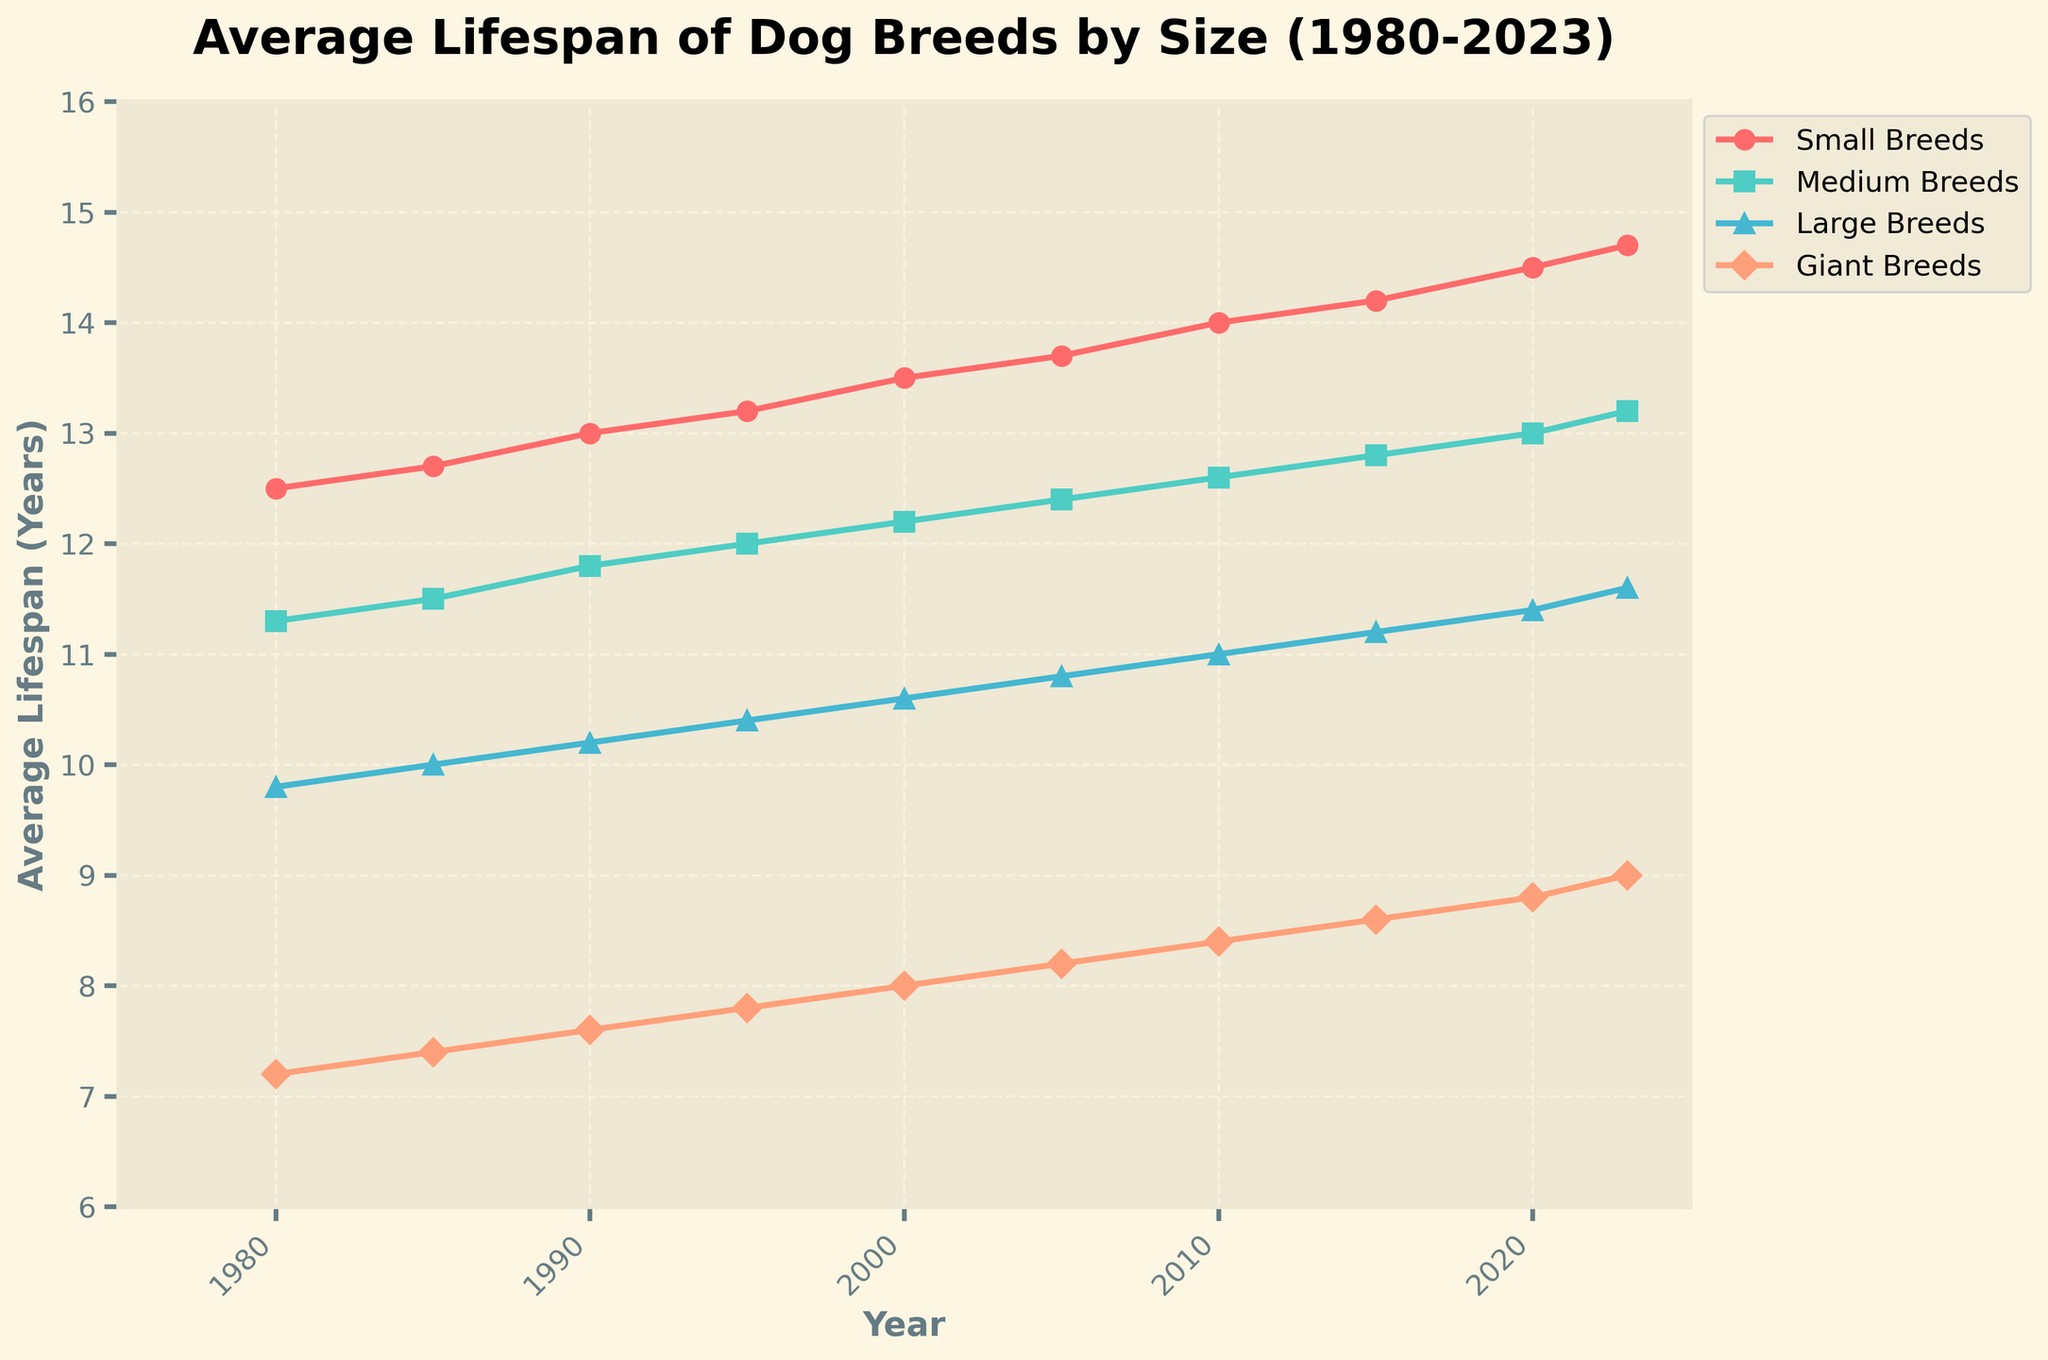What was the average lifespan of Small Breeds in 1980? According to the figure, the average lifespan of Small Breeds in 1980 is indicated by the first data point plotted on the line for Small Breeds, which is 12.5 years.
Answer: 12.5 years Which breed size category had the lowest average lifespan in 2023? By looking at the data points for 2023, Giant Breeds have the lowest average lifespan of 9.0 years, as it is the lowest value plotted among all four breed size categories.
Answer: Giant Breeds How much did the lifespan of Medium Breeds increase from 1980 to 2023? The lifespan of Medium Breeds in 1980 was 11.3 years and it increased to 13.2 years by 2023. The increase is calculated as 13.2 - 11.3 = 1.9 years.
Answer: 1.9 years Between which years did Giant Breeds see the highest rate of increase in their average lifespan? By observing the plot, the rate of increase between each period for Giant Breeds can be compared. The highest rate of increase appears between 1995 and 2000, as the slope of the line representing Giant Breeds is steepest between these years. The lifespan increased from 7.8 to 8.0, indicating a 0.2-year increase over a 5-year period.
Answer: 1995 to 2000 What is the approximate average lifespan of Large Breeds in the year 2005 compared to Small Breeds in the same year? From the plot, the average lifespan for Large Breeds in 2005 is 10.8 years, while for Small Breeds, it is 13.7 years. Therefore, Small Breeds have approximately a 2.9 year longer lifespan than Large Breeds in 2005 (13.7 - 10.8 = 2.9 years).
Answer: 2.9 years Which breed size category showed the most consistent increase in lifespan over the years? By observing the trends in the plot, Small Breeds showed the most consistent increase in lifespan, as their line has a consistent upward slope from 1980 to 2023 without any significant fluctuations.
Answer: Small Breeds How does the average lifespan of Giant Breeds in 2023 compare to the average lifespan of Medium Breeds in 1980? The plot indicates the average lifespan of Giant Breeds in 2023 is 9.0 years, while the lifespan for Medium Breeds in 1980 is 11.3 years. This means the lifespan of Giant Breeds in 2023 is still lower by 2.3 years compared to Medium Breeds in 1980 (11.3 - 9.0 = 2.3).
Answer: 2.3 years 